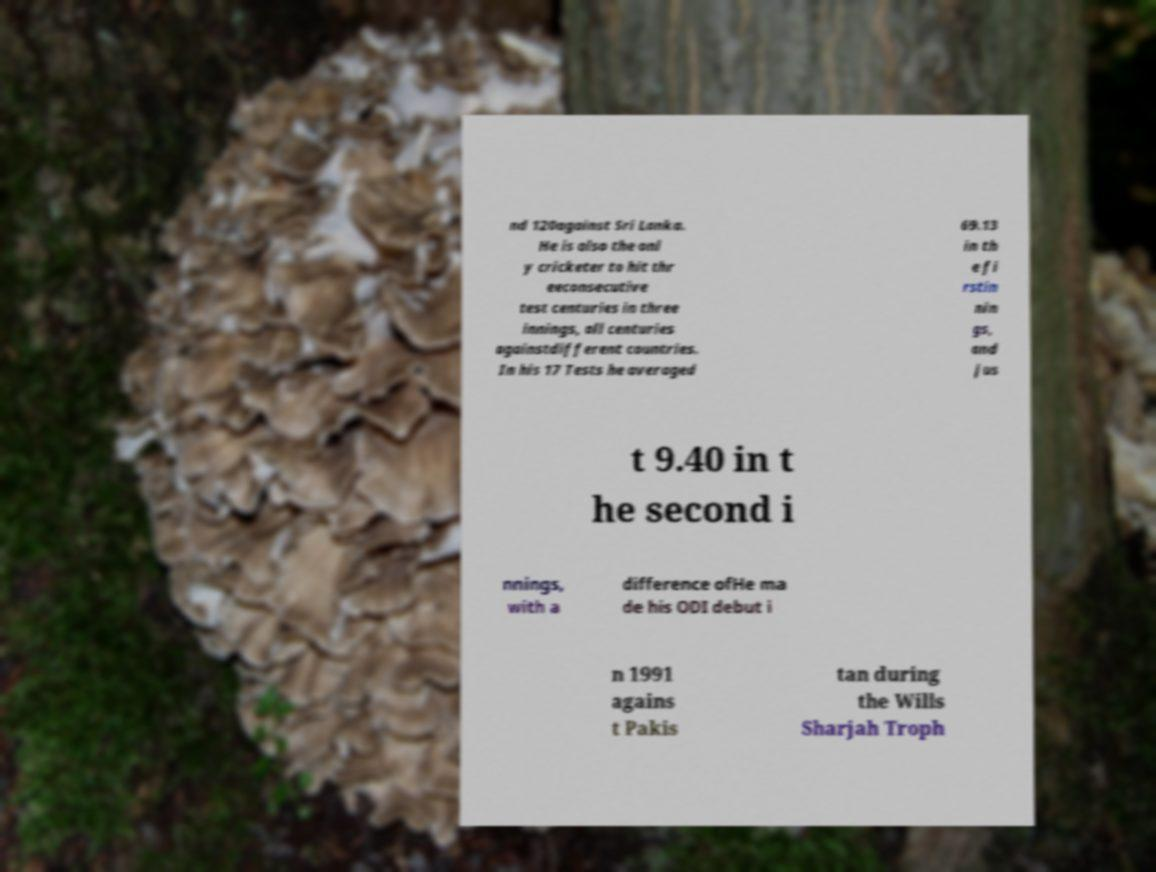What details can you provide about the background texture in this image? The background of the image features what appears to be a natural texture, potentially from a type of fungus or lichen growing on a tree. These formations are typically found in moist environments and can vary widely in shape, size, and color.  What significance could this fungus have in its natural habitat? Fungi play critical roles in their ecosystems, including decomposing organic material, which recycles nutrients back into the soil. They can also form symbiotic relationships with plants, aiding in water and nutrient absorption. 